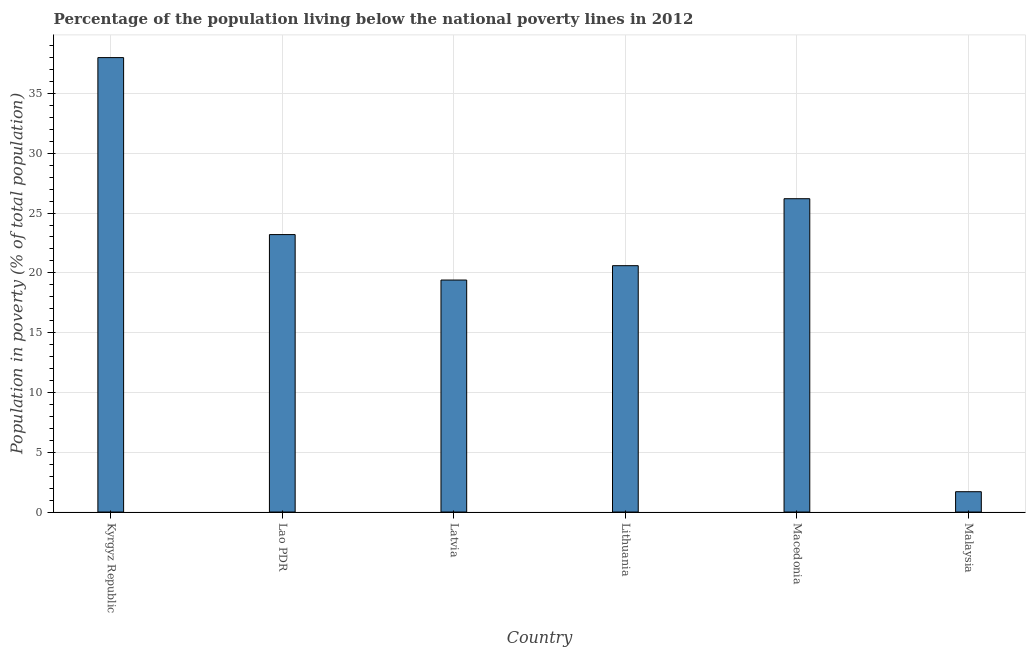Does the graph contain grids?
Offer a terse response. Yes. What is the title of the graph?
Provide a succinct answer. Percentage of the population living below the national poverty lines in 2012. What is the label or title of the X-axis?
Your response must be concise. Country. What is the label or title of the Y-axis?
Make the answer very short. Population in poverty (% of total population). What is the percentage of population living below poverty line in Lithuania?
Offer a very short reply. 20.6. Across all countries, what is the minimum percentage of population living below poverty line?
Give a very brief answer. 1.7. In which country was the percentage of population living below poverty line maximum?
Your response must be concise. Kyrgyz Republic. In which country was the percentage of population living below poverty line minimum?
Your answer should be very brief. Malaysia. What is the sum of the percentage of population living below poverty line?
Give a very brief answer. 129.1. What is the difference between the percentage of population living below poverty line in Lao PDR and Latvia?
Keep it short and to the point. 3.8. What is the average percentage of population living below poverty line per country?
Provide a succinct answer. 21.52. What is the median percentage of population living below poverty line?
Ensure brevity in your answer.  21.9. What is the ratio of the percentage of population living below poverty line in Macedonia to that in Malaysia?
Keep it short and to the point. 15.41. Is the difference between the percentage of population living below poverty line in Kyrgyz Republic and Malaysia greater than the difference between any two countries?
Your response must be concise. Yes. Is the sum of the percentage of population living below poverty line in Latvia and Lithuania greater than the maximum percentage of population living below poverty line across all countries?
Offer a terse response. Yes. What is the difference between the highest and the lowest percentage of population living below poverty line?
Your answer should be very brief. 36.3. In how many countries, is the percentage of population living below poverty line greater than the average percentage of population living below poverty line taken over all countries?
Provide a succinct answer. 3. How many bars are there?
Provide a short and direct response. 6. Are all the bars in the graph horizontal?
Ensure brevity in your answer.  No. Are the values on the major ticks of Y-axis written in scientific E-notation?
Ensure brevity in your answer.  No. What is the Population in poverty (% of total population) in Kyrgyz Republic?
Offer a very short reply. 38. What is the Population in poverty (% of total population) in Lao PDR?
Provide a short and direct response. 23.2. What is the Population in poverty (% of total population) of Latvia?
Your response must be concise. 19.4. What is the Population in poverty (% of total population) of Lithuania?
Ensure brevity in your answer.  20.6. What is the Population in poverty (% of total population) in Macedonia?
Offer a very short reply. 26.2. What is the Population in poverty (% of total population) in Malaysia?
Make the answer very short. 1.7. What is the difference between the Population in poverty (% of total population) in Kyrgyz Republic and Lao PDR?
Ensure brevity in your answer.  14.8. What is the difference between the Population in poverty (% of total population) in Kyrgyz Republic and Lithuania?
Your answer should be compact. 17.4. What is the difference between the Population in poverty (% of total population) in Kyrgyz Republic and Malaysia?
Your answer should be compact. 36.3. What is the difference between the Population in poverty (% of total population) in Lao PDR and Latvia?
Give a very brief answer. 3.8. What is the difference between the Population in poverty (% of total population) in Lao PDR and Lithuania?
Offer a very short reply. 2.6. What is the difference between the Population in poverty (% of total population) in Lao PDR and Macedonia?
Your response must be concise. -3. What is the difference between the Population in poverty (% of total population) in Latvia and Malaysia?
Offer a very short reply. 17.7. What is the difference between the Population in poverty (% of total population) in Lithuania and Macedonia?
Keep it short and to the point. -5.6. What is the difference between the Population in poverty (% of total population) in Lithuania and Malaysia?
Make the answer very short. 18.9. What is the ratio of the Population in poverty (% of total population) in Kyrgyz Republic to that in Lao PDR?
Your answer should be compact. 1.64. What is the ratio of the Population in poverty (% of total population) in Kyrgyz Republic to that in Latvia?
Make the answer very short. 1.96. What is the ratio of the Population in poverty (% of total population) in Kyrgyz Republic to that in Lithuania?
Your response must be concise. 1.84. What is the ratio of the Population in poverty (% of total population) in Kyrgyz Republic to that in Macedonia?
Make the answer very short. 1.45. What is the ratio of the Population in poverty (% of total population) in Kyrgyz Republic to that in Malaysia?
Make the answer very short. 22.35. What is the ratio of the Population in poverty (% of total population) in Lao PDR to that in Latvia?
Keep it short and to the point. 1.2. What is the ratio of the Population in poverty (% of total population) in Lao PDR to that in Lithuania?
Provide a short and direct response. 1.13. What is the ratio of the Population in poverty (% of total population) in Lao PDR to that in Macedonia?
Offer a very short reply. 0.89. What is the ratio of the Population in poverty (% of total population) in Lao PDR to that in Malaysia?
Your response must be concise. 13.65. What is the ratio of the Population in poverty (% of total population) in Latvia to that in Lithuania?
Your answer should be compact. 0.94. What is the ratio of the Population in poverty (% of total population) in Latvia to that in Macedonia?
Make the answer very short. 0.74. What is the ratio of the Population in poverty (% of total population) in Latvia to that in Malaysia?
Your answer should be very brief. 11.41. What is the ratio of the Population in poverty (% of total population) in Lithuania to that in Macedonia?
Provide a short and direct response. 0.79. What is the ratio of the Population in poverty (% of total population) in Lithuania to that in Malaysia?
Offer a terse response. 12.12. What is the ratio of the Population in poverty (% of total population) in Macedonia to that in Malaysia?
Your answer should be compact. 15.41. 